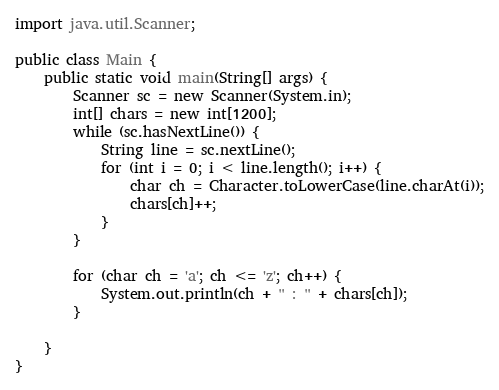Convert code to text. <code><loc_0><loc_0><loc_500><loc_500><_Java_>import java.util.Scanner;

public class Main {
	public static void main(String[] args) {
		Scanner sc = new Scanner(System.in);
		int[] chars = new int[1200];
		while (sc.hasNextLine()) {
			String line = sc.nextLine();
			for (int i = 0; i < line.length(); i++) {
				char ch = Character.toLowerCase(line.charAt(i));
				chars[ch]++;
			}
		}

		for (char ch = 'a'; ch <= 'z'; ch++) {
			System.out.println(ch + " : " + chars[ch]);
		}

	}
}</code> 